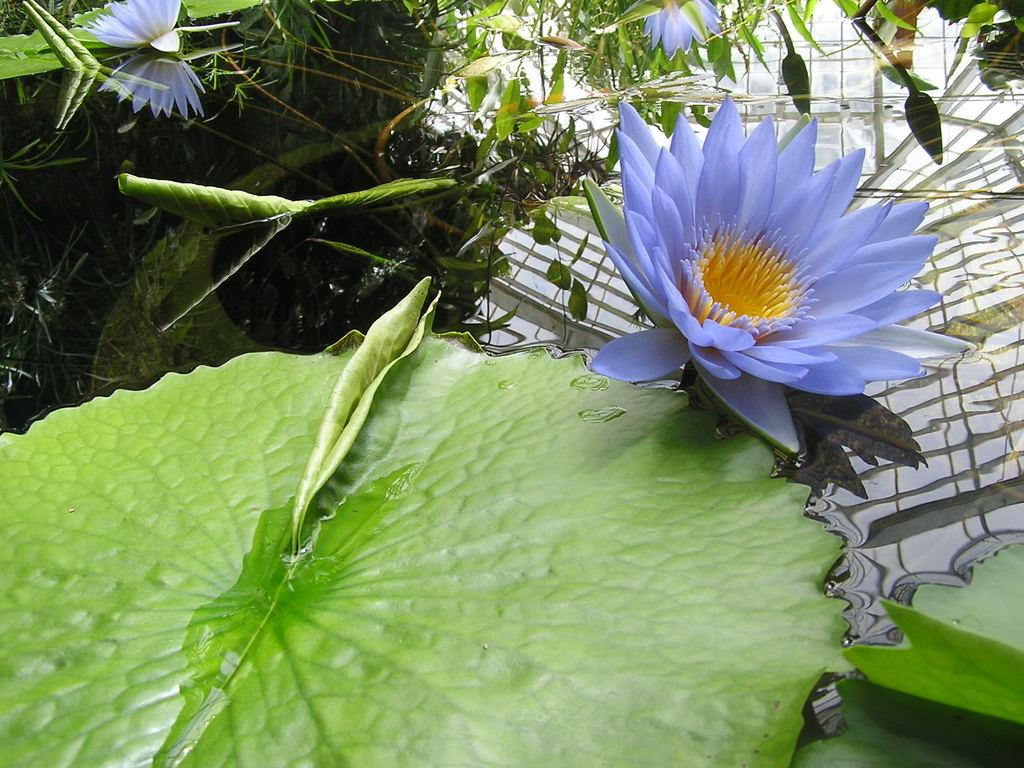What type of plants can be seen in the image? There are flowers and leaves in the image. Where are the flowers and leaves located? The flowers and leaves are on the water. What type of structure can be seen in the field in the image? There is no field or structure present in the image; it features flowers and leaves on the water. 